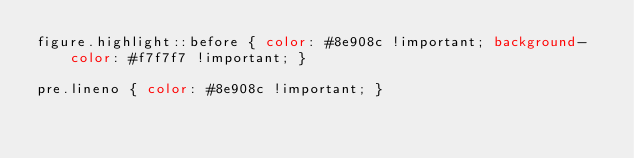<code> <loc_0><loc_0><loc_500><loc_500><_CSS_>figure.highlight::before { color: #8e908c !important; background-color: #f7f7f7 !important; }

pre.lineno { color: #8e908c !important; }
</code> 